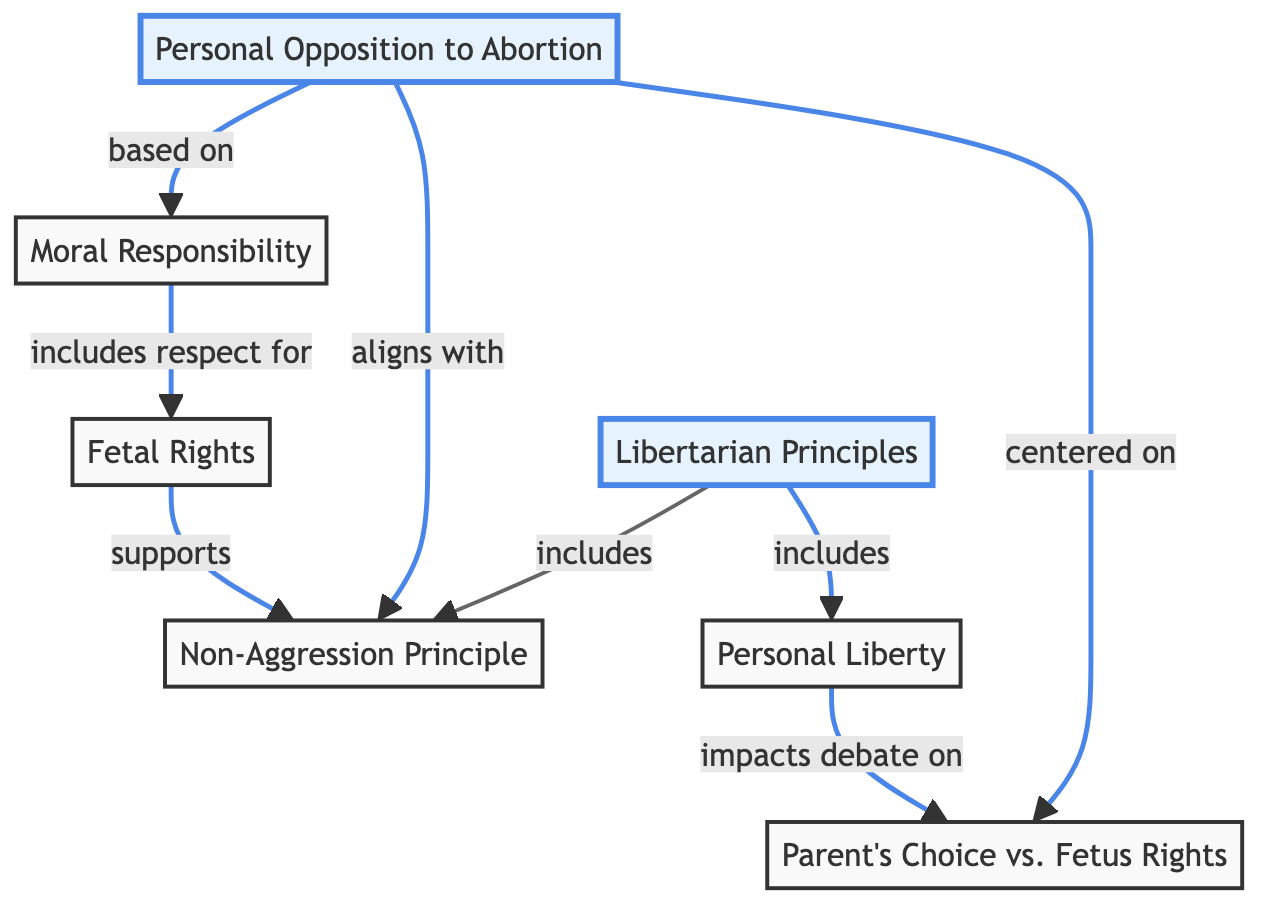What's the number of main nodes in the diagram? The diagram includes seven main nodes: Libertarian Principles, Non-Aggression Principle, Personal Liberty, Personal Opposition to Abortion, Moral Responsibility, Fetal Rights, and Parent's Choice vs. Fetus Rights. Counting each distinct node gives us a total of seven.
Answer: 7 Which principle is emphasized alongside Personal Opposition to Abortion? The diagram indicates that Personal Opposition to Abortion aligns with the Non-Aggression Principle, as indicated by the arrow connecting these two nodes. This shows the relationship and emphasizes that personal opposition is grounded in libertarian ethics.
Answer: Non-Aggression Principle What does Moral Responsibility include? According to the diagram, Moral Responsibility includes respect for Fetal Rights, which is depicted through the direct connection from one node to the other. This indicates that moral responsibility directly encompasses the consideration for fetal rights.
Answer: respect for Fetal Rights How does Personal Liberty impact the debate on Parent's Choice vs. Fetus Rights? The diagram shows an arrow going from Personal Liberty to Parent's Choice vs. Fetus Rights, indicating that personal liberty plays a critical role in this debate. It suggests that the concept of individual freedom significantly influences decisions related to this issue.
Answer: impacts debate on What are the two main components included in Libertarian Principles? The diagram shows that Libertarian Principles include both the Non-Aggression Principle and Personal Liberty. This indicates that these two ethical guidelines form the foundation of libertarian thought concerning various issues, including abortion.
Answer: Non-Aggression Principle, Personal Liberty How do Fetal Rights support the Non-Aggression Principle? The diagram indicates that Fetal Rights support the Non-Aggression Principle, showing a direct relationship. This suggests that recognizing fetal rights is consistent with the broader ethical guideline of non-aggression promoted by libertarian beliefs.
Answer: supports 